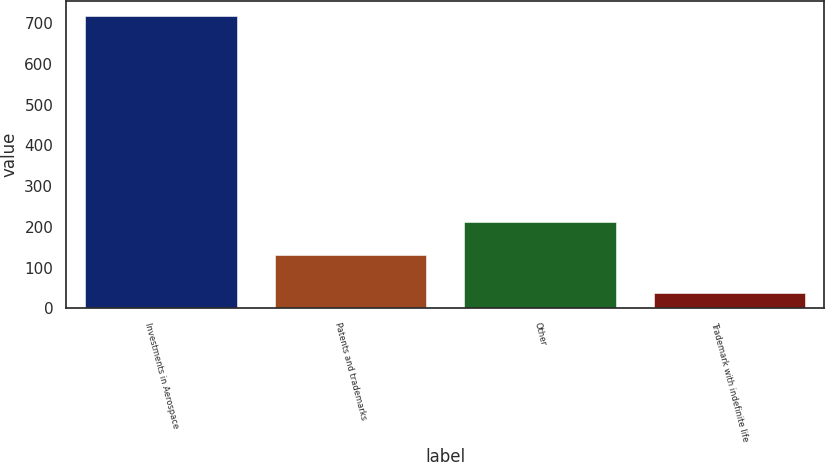<chart> <loc_0><loc_0><loc_500><loc_500><bar_chart><fcel>Investments in Aerospace<fcel>Patents and trademarks<fcel>Other<fcel>Trademark with indefinite life<nl><fcel>719<fcel>130<fcel>212<fcel>37<nl></chart> 